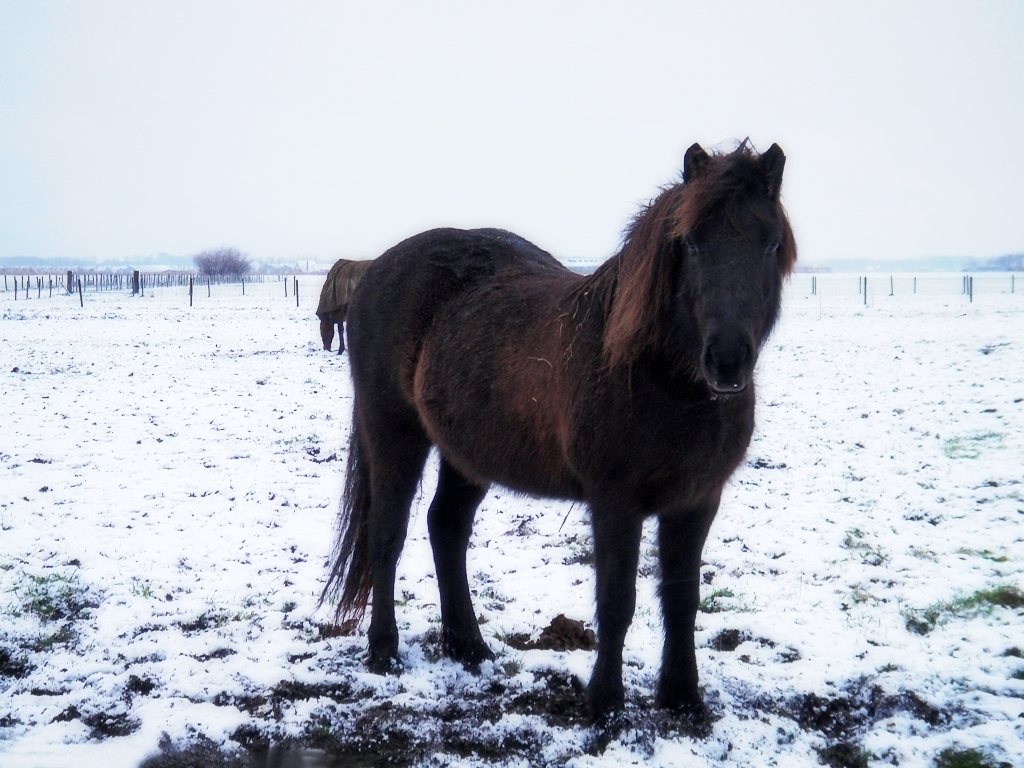How does the overall atmosphere of the scene affect the mood of the picture? The overcast sky and the presence of snow create a serene, somewhat sombre atmosphere. The diffused light softens the landscape, emphasizing the quietness and stillness of the scene. This gives the image a tranquil, yet cool and isolated mood. 